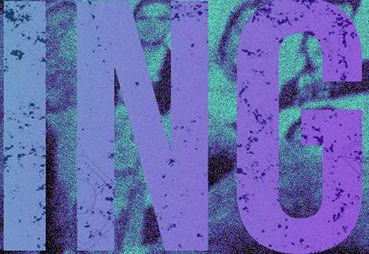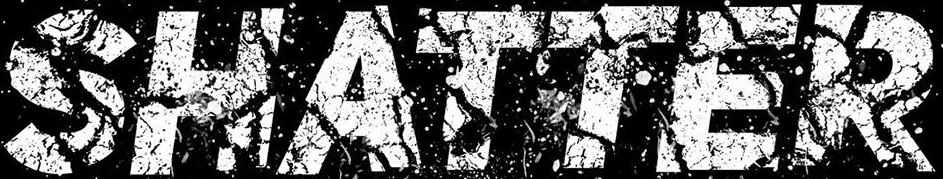What words are shown in these images in order, separated by a semicolon? ING; SHATTER 